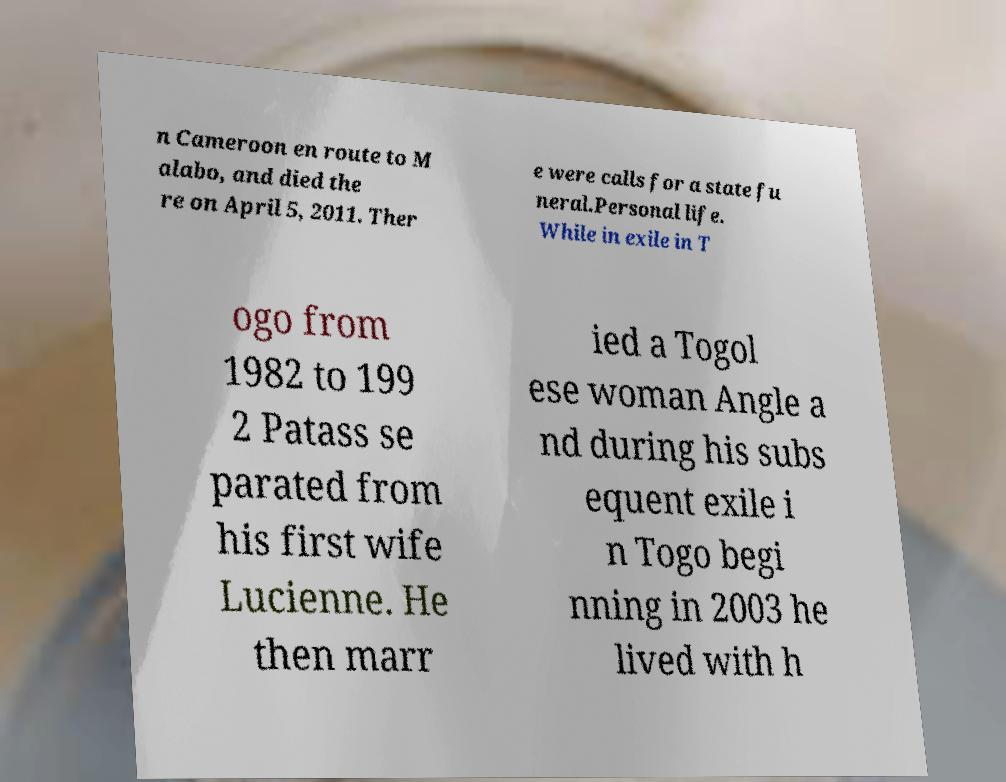What messages or text are displayed in this image? I need them in a readable, typed format. n Cameroon en route to M alabo, and died the re on April 5, 2011. Ther e were calls for a state fu neral.Personal life. While in exile in T ogo from 1982 to 199 2 Patass se parated from his first wife Lucienne. He then marr ied a Togol ese woman Angle a nd during his subs equent exile i n Togo begi nning in 2003 he lived with h 